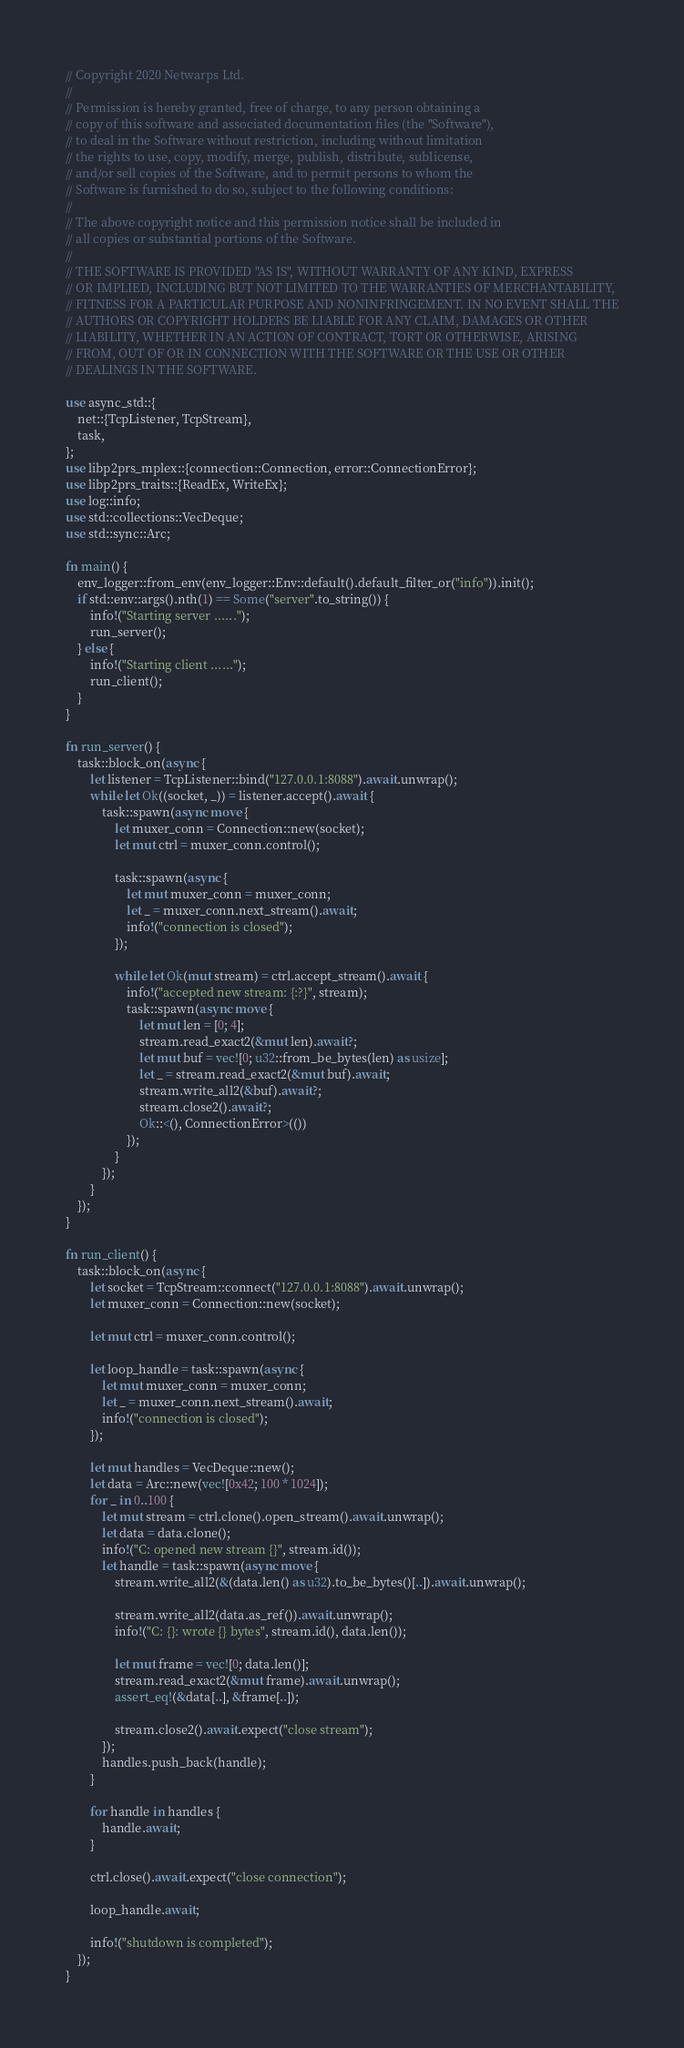Convert code to text. <code><loc_0><loc_0><loc_500><loc_500><_Rust_>// Copyright 2020 Netwarps Ltd.
//
// Permission is hereby granted, free of charge, to any person obtaining a
// copy of this software and associated documentation files (the "Software"),
// to deal in the Software without restriction, including without limitation
// the rights to use, copy, modify, merge, publish, distribute, sublicense,
// and/or sell copies of the Software, and to permit persons to whom the
// Software is furnished to do so, subject to the following conditions:
//
// The above copyright notice and this permission notice shall be included in
// all copies or substantial portions of the Software.
//
// THE SOFTWARE IS PROVIDED "AS IS", WITHOUT WARRANTY OF ANY KIND, EXPRESS
// OR IMPLIED, INCLUDING BUT NOT LIMITED TO THE WARRANTIES OF MERCHANTABILITY,
// FITNESS FOR A PARTICULAR PURPOSE AND NONINFRINGEMENT. IN NO EVENT SHALL THE
// AUTHORS OR COPYRIGHT HOLDERS BE LIABLE FOR ANY CLAIM, DAMAGES OR OTHER
// LIABILITY, WHETHER IN AN ACTION OF CONTRACT, TORT OR OTHERWISE, ARISING
// FROM, OUT OF OR IN CONNECTION WITH THE SOFTWARE OR THE USE OR OTHER
// DEALINGS IN THE SOFTWARE.

use async_std::{
    net::{TcpListener, TcpStream},
    task,
};
use libp2prs_mplex::{connection::Connection, error::ConnectionError};
use libp2prs_traits::{ReadEx, WriteEx};
use log::info;
use std::collections::VecDeque;
use std::sync::Arc;

fn main() {
    env_logger::from_env(env_logger::Env::default().default_filter_or("info")).init();
    if std::env::args().nth(1) == Some("server".to_string()) {
        info!("Starting server ......");
        run_server();
    } else {
        info!("Starting client ......");
        run_client();
    }
}

fn run_server() {
    task::block_on(async {
        let listener = TcpListener::bind("127.0.0.1:8088").await.unwrap();
        while let Ok((socket, _)) = listener.accept().await {
            task::spawn(async move {
                let muxer_conn = Connection::new(socket);
                let mut ctrl = muxer_conn.control();

                task::spawn(async {
                    let mut muxer_conn = muxer_conn;
                    let _ = muxer_conn.next_stream().await;
                    info!("connection is closed");
                });

                while let Ok(mut stream) = ctrl.accept_stream().await {
                    info!("accepted new stream: {:?}", stream);
                    task::spawn(async move {
                        let mut len = [0; 4];
                        stream.read_exact2(&mut len).await?;
                        let mut buf = vec![0; u32::from_be_bytes(len) as usize];
                        let _ = stream.read_exact2(&mut buf).await;
                        stream.write_all2(&buf).await?;
                        stream.close2().await?;
                        Ok::<(), ConnectionError>(())
                    });
                }
            });
        }
    });
}

fn run_client() {
    task::block_on(async {
        let socket = TcpStream::connect("127.0.0.1:8088").await.unwrap();
        let muxer_conn = Connection::new(socket);

        let mut ctrl = muxer_conn.control();

        let loop_handle = task::spawn(async {
            let mut muxer_conn = muxer_conn;
            let _ = muxer_conn.next_stream().await;
            info!("connection is closed");
        });

        let mut handles = VecDeque::new();
        let data = Arc::new(vec![0x42; 100 * 1024]);
        for _ in 0..100 {
            let mut stream = ctrl.clone().open_stream().await.unwrap();
            let data = data.clone();
            info!("C: opened new stream {}", stream.id());
            let handle = task::spawn(async move {
                stream.write_all2(&(data.len() as u32).to_be_bytes()[..]).await.unwrap();

                stream.write_all2(data.as_ref()).await.unwrap();
                info!("C: {}: wrote {} bytes", stream.id(), data.len());

                let mut frame = vec![0; data.len()];
                stream.read_exact2(&mut frame).await.unwrap();
                assert_eq!(&data[..], &frame[..]);

                stream.close2().await.expect("close stream");
            });
            handles.push_back(handle);
        }

        for handle in handles {
            handle.await;
        }

        ctrl.close().await.expect("close connection");

        loop_handle.await;

        info!("shutdown is completed");
    });
}
</code> 